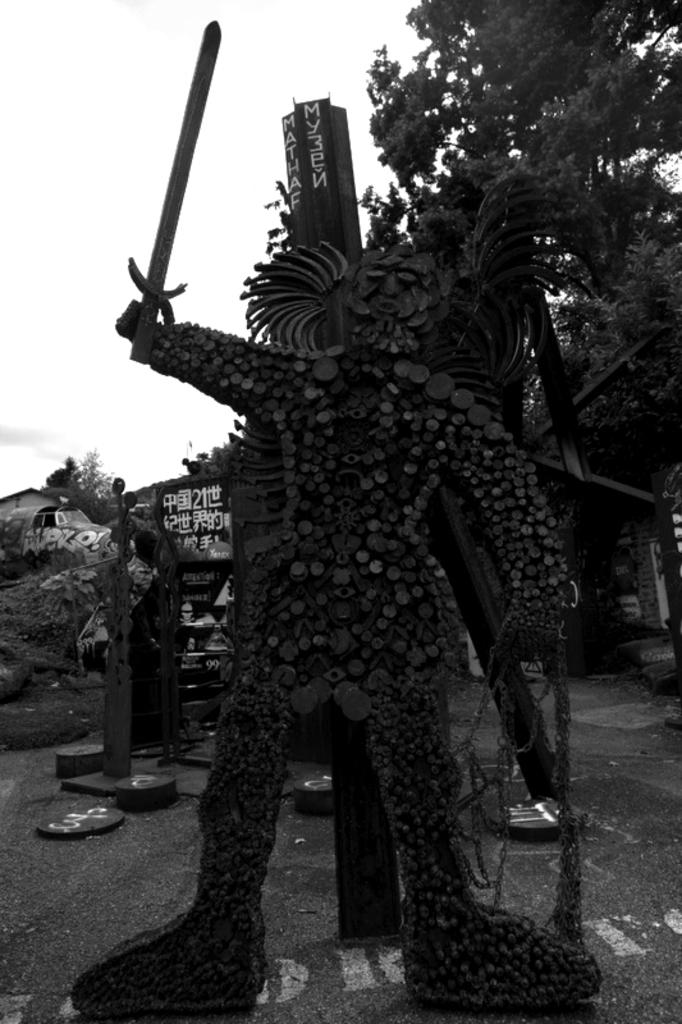What is the color scheme of the image? The image is black and white. What is the main subject in the foreground of the image? There is a statue in the foreground of the image. What is located behind the statue? There is a pole behind the statue. What type of natural elements can be seen in the image? Trees are visible in the image. What other objects can be seen in the image besides the statue and pole? There are other objects in the image. What is the price of the dog featured in the advertisement in the image? There is no dog or advertisement present in the image. 